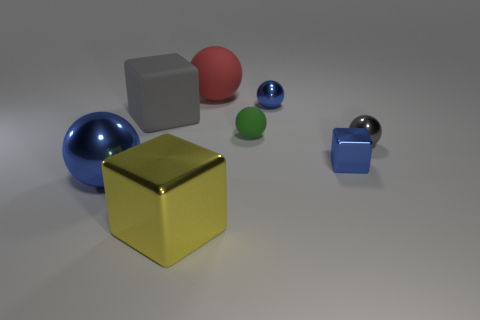Add 1 tiny metallic blocks. How many objects exist? 9 Subtract all cubes. How many objects are left? 5 Add 4 shiny objects. How many shiny objects are left? 9 Add 5 big yellow metal spheres. How many big yellow metal spheres exist? 5 Subtract 1 gray blocks. How many objects are left? 7 Subtract all blue metal balls. Subtract all green rubber blocks. How many objects are left? 6 